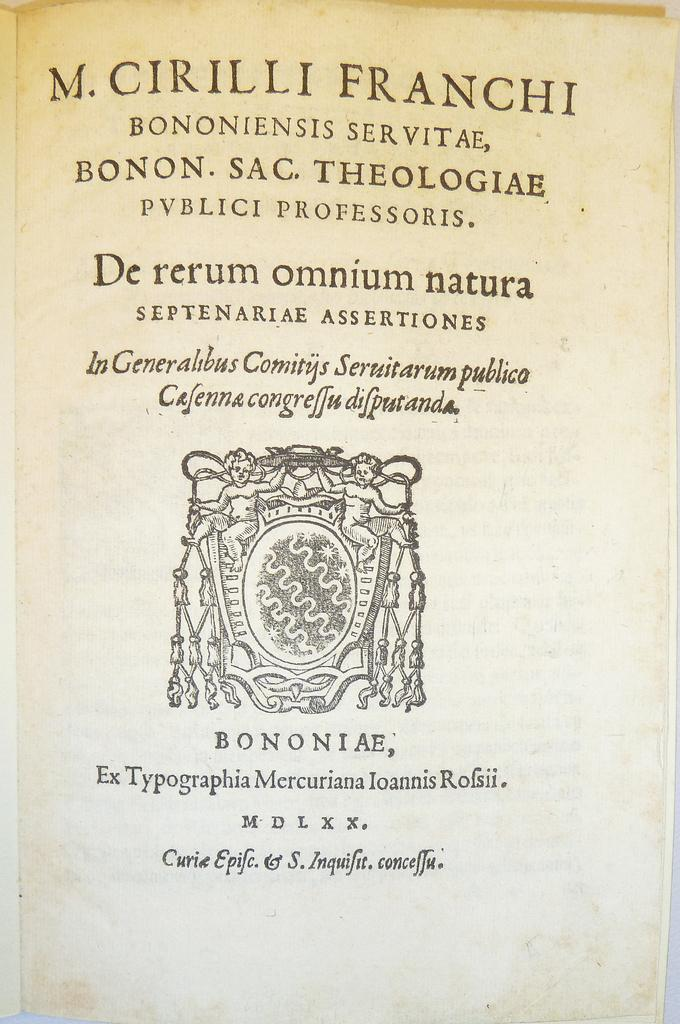<image>
Present a compact description of the photo's key features. The front cover of a french book with a latin title in fine line print. 